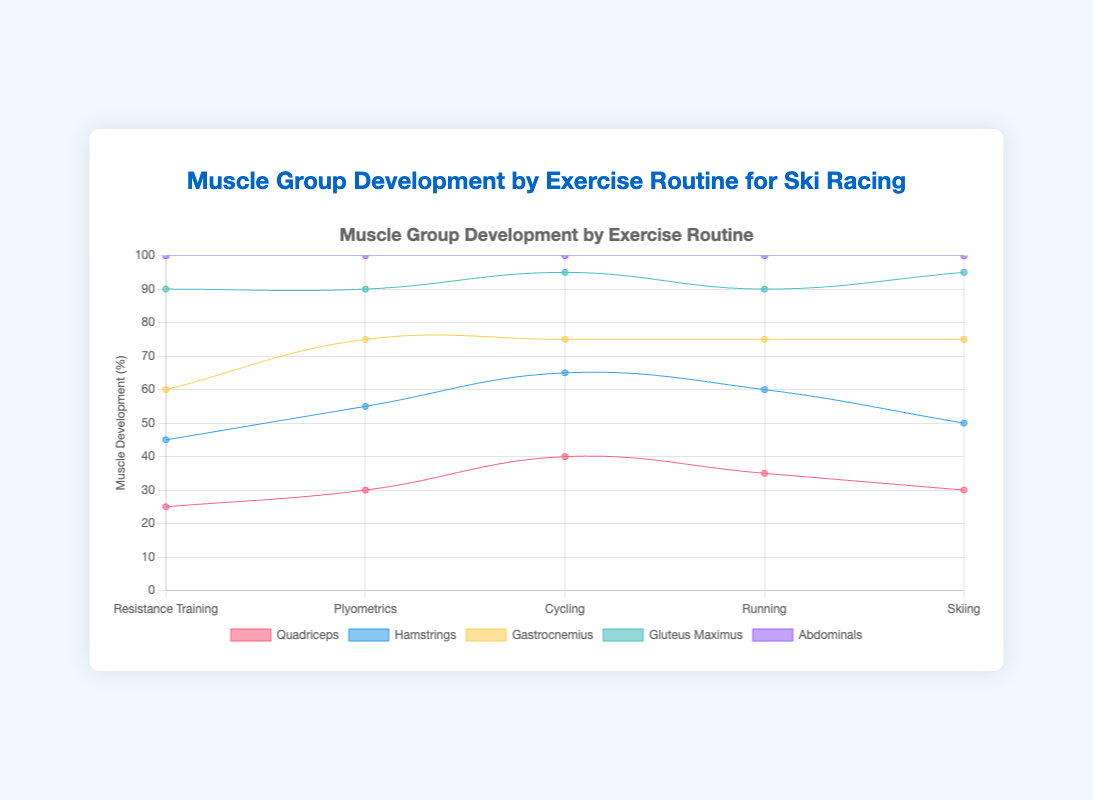What is the title of the chart? The title of the chart is displayed at the top of the figure. You can clearly see it as "Muscle Group Development by Exercise Routine."
Answer: Muscle Group Development by Exercise Routine Which exercise routine contributes the most to Quadriceps development? Look at the area corresponding to the Quadriceps development for each exercise routine. The highest value can be observed under the "Cycling" routine.
Answer: Cycling How many different muscle groups are shown in the chart? Identify the distinct colored sections representing the muscle groups in the stacked area chart. There are five different regions, each corresponding to one muscle group.
Answer: 5 What is the combined muscle development percentage for Gluteus Maximus and Abdominals in the Skiing routine? Locate the Skiing routine in the chart and add the values for Gluteus Maximus (20%) and Abdominals (5%). The sum of these percentages is 25%.
Answer: 25% Which muscle group has the smallest contribution in the Plyometrics routine? In the Plyometrics routine section of the chart, identify the muscle group with the smallest area. The Abdominals with 10% is the smallest.
Answer: Abdominals Compare the development of Hamstrings in Running and Skiing routines. Which routine has a higher percentage? Look at the Hamstrings area for both Running and Skiing routines. Both have a Hamstrings development of 25%, so they are equal.
Answer: Equal Which routine provides the greatest overall muscle development for Quadriceps? The routine with the largest area for Quadriceps across all the exercise routines is Cycling with 40%.
Answer: Cycling If you aimed to improve your Gluteus Maximus, which exercise routine would you choose and why? To determine the best routine for Gluteus Maximus, look for the routine with the highest percentage in that area. Resistance Training offers the highest development at 30%.
Answer: Resistance Training How does Gastrocnemius development in Skiing compare to Resistance Training? Compare the Gastrocnemius section of the chart for Skiing (25%) and Resistance Training (15%). Skiing has a higher percentage.
Answer: Skiing For an exercise routine focusing on overall balanced muscle development, which routine would you consider based on the chart? Look for an exercise routine where muscle development percentages are evenly distributed among different muscle groups. Plyometrics shows a relatively balanced development for all its muscle groups.
Answer: Plyometrics 